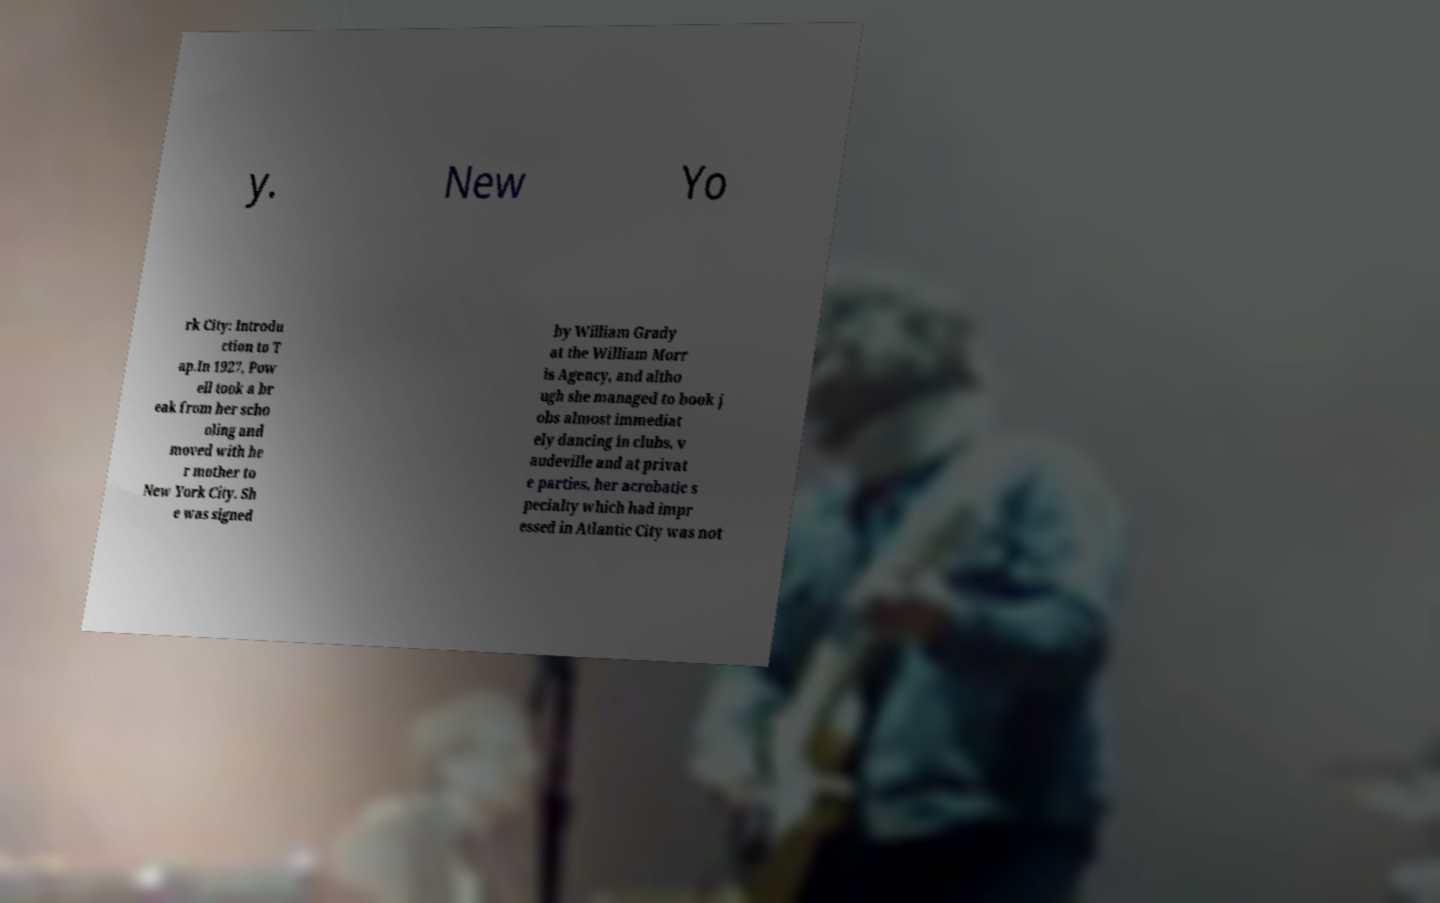Please read and relay the text visible in this image. What does it say? y. New Yo rk City: Introdu ction to T ap.In 1927, Pow ell took a br eak from her scho oling and moved with he r mother to New York City. Sh e was signed by William Grady at the William Morr is Agency, and altho ugh she managed to book j obs almost immediat ely dancing in clubs, v audeville and at privat e parties, her acrobatic s pecialty which had impr essed in Atlantic City was not 